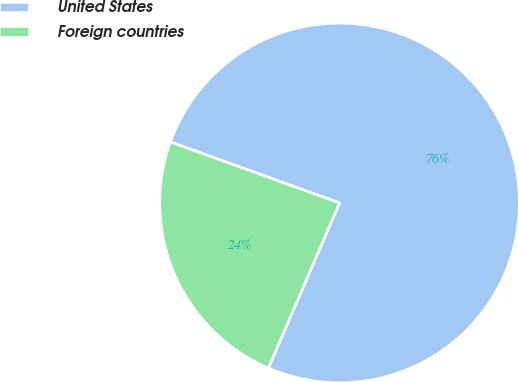<chart> <loc_0><loc_0><loc_500><loc_500><pie_chart><fcel>United States<fcel>Foreign countries<nl><fcel>75.98%<fcel>24.02%<nl></chart> 